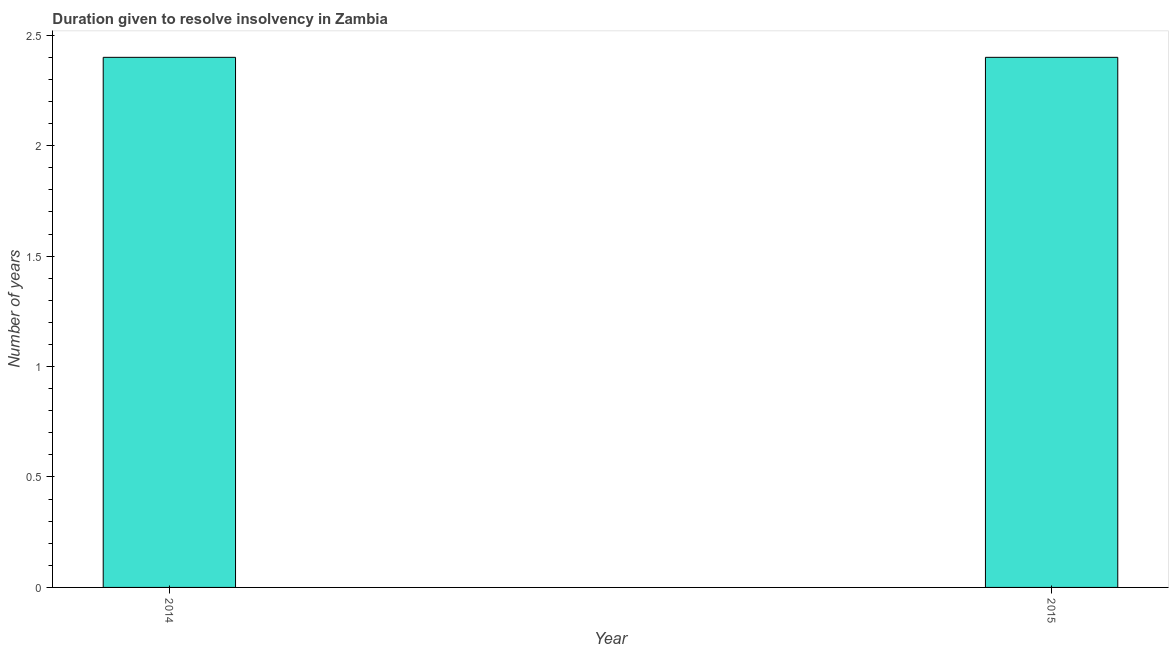What is the title of the graph?
Your answer should be compact. Duration given to resolve insolvency in Zambia. What is the label or title of the Y-axis?
Provide a short and direct response. Number of years. Across all years, what is the maximum number of years to resolve insolvency?
Give a very brief answer. 2.4. Across all years, what is the minimum number of years to resolve insolvency?
Give a very brief answer. 2.4. What is the sum of the number of years to resolve insolvency?
Make the answer very short. 4.8. What is the difference between the number of years to resolve insolvency in 2014 and 2015?
Your answer should be very brief. 0. In how many years, is the number of years to resolve insolvency greater than 2.4 ?
Provide a succinct answer. 0. In how many years, is the number of years to resolve insolvency greater than the average number of years to resolve insolvency taken over all years?
Give a very brief answer. 0. Are all the bars in the graph horizontal?
Offer a terse response. No. What is the Number of years in 2015?
Offer a very short reply. 2.4. What is the difference between the Number of years in 2014 and 2015?
Your answer should be compact. 0. What is the ratio of the Number of years in 2014 to that in 2015?
Provide a succinct answer. 1. 